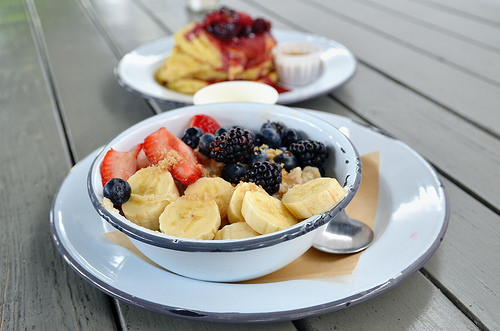<image>
Is the fruit on the bowl? Yes. Looking at the image, I can see the fruit is positioned on top of the bowl, with the bowl providing support. Is there a banana on the spoon? No. The banana is not positioned on the spoon. They may be near each other, but the banana is not supported by or resting on top of the spoon. 